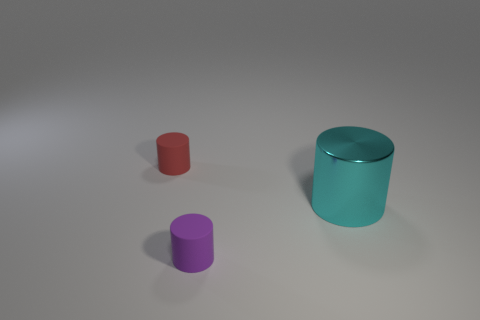Subtract all tiny cylinders. How many cylinders are left? 1 Add 3 tiny things. How many objects exist? 6 Subtract all red rubber cylinders. Subtract all purple objects. How many objects are left? 1 Add 1 small red things. How many small red things are left? 2 Add 1 large cyan matte objects. How many large cyan matte objects exist? 1 Subtract 0 gray cubes. How many objects are left? 3 